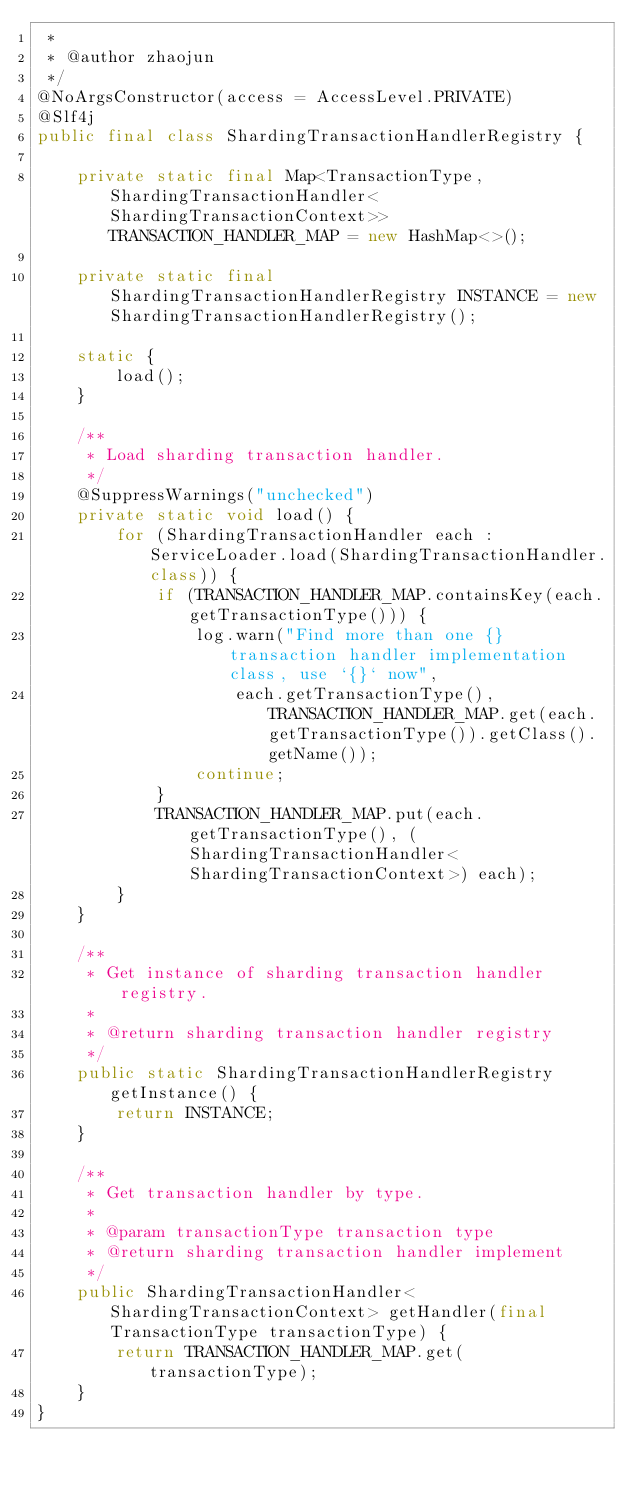<code> <loc_0><loc_0><loc_500><loc_500><_Java_> *
 * @author zhaojun
 */
@NoArgsConstructor(access = AccessLevel.PRIVATE)
@Slf4j
public final class ShardingTransactionHandlerRegistry {
    
    private static final Map<TransactionType, ShardingTransactionHandler<ShardingTransactionContext>> TRANSACTION_HANDLER_MAP = new HashMap<>();
    
    private static final ShardingTransactionHandlerRegistry INSTANCE = new ShardingTransactionHandlerRegistry();
    
    static {
        load();
    }
    
    /**
     * Load sharding transaction handler.
     */
    @SuppressWarnings("unchecked")
    private static void load() {
        for (ShardingTransactionHandler each : ServiceLoader.load(ShardingTransactionHandler.class)) {
            if (TRANSACTION_HANDLER_MAP.containsKey(each.getTransactionType())) {
                log.warn("Find more than one {} transaction handler implementation class, use `{}` now",
                    each.getTransactionType(), TRANSACTION_HANDLER_MAP.get(each.getTransactionType()).getClass().getName());
                continue;
            }
            TRANSACTION_HANDLER_MAP.put(each.getTransactionType(), (ShardingTransactionHandler<ShardingTransactionContext>) each);
        }
    }
    
    /**
     * Get instance of sharding transaction handler registry.
     *
     * @return sharding transaction handler registry
     */
    public static ShardingTransactionHandlerRegistry getInstance() {
        return INSTANCE;
    }
    
    /**
     * Get transaction handler by type.
     *
     * @param transactionType transaction type
     * @return sharding transaction handler implement
     */
    public ShardingTransactionHandler<ShardingTransactionContext> getHandler(final TransactionType transactionType) {
        return TRANSACTION_HANDLER_MAP.get(transactionType);
    }
}
</code> 